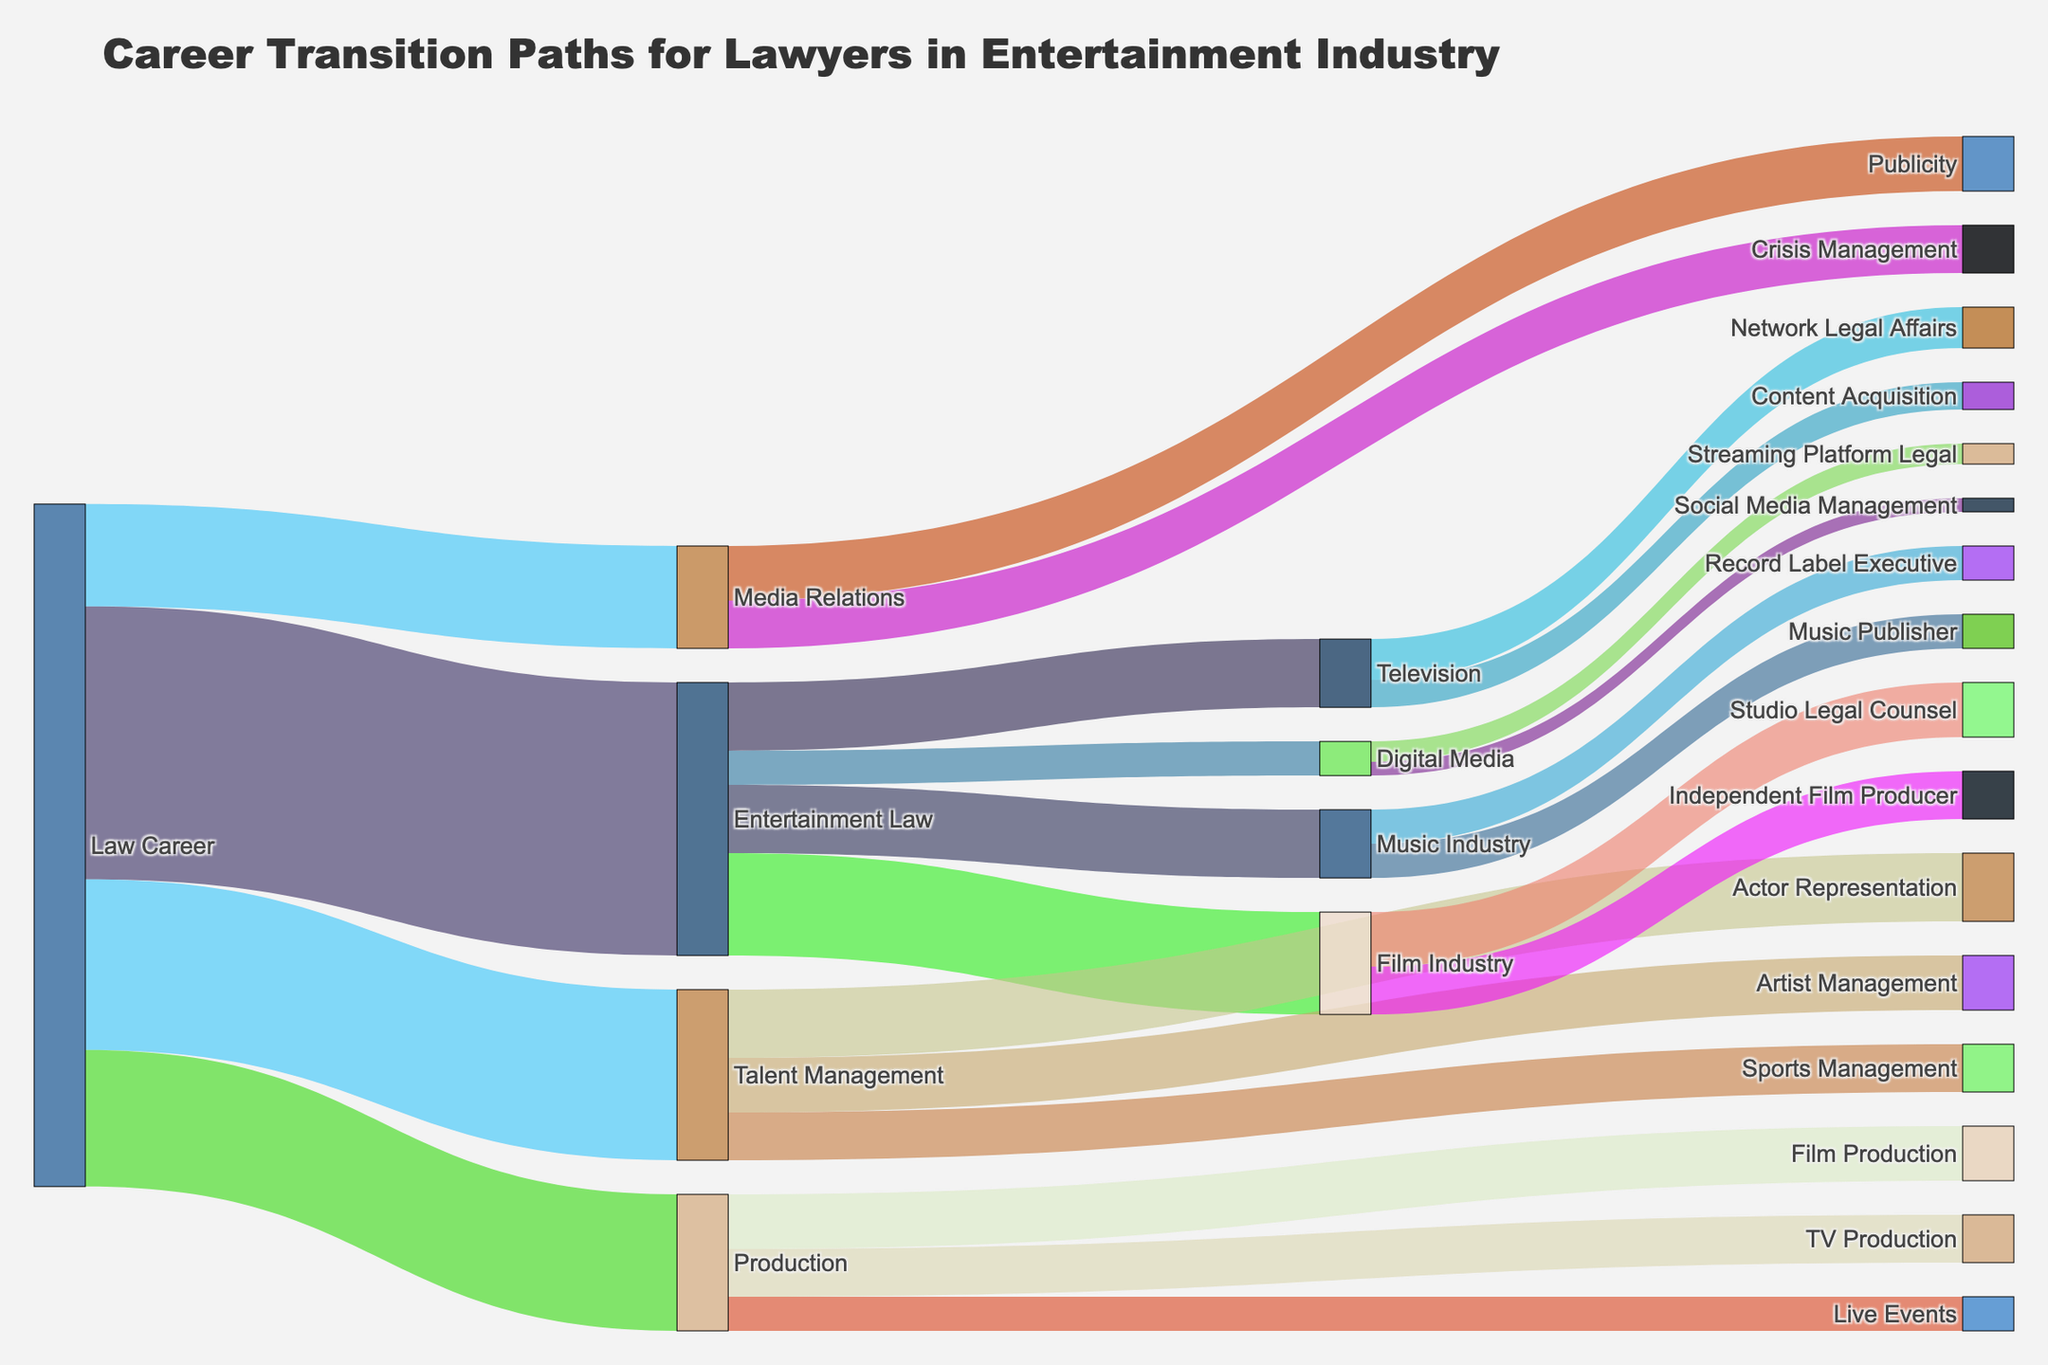How many different paths lead from a Law Career to roles in the Film Industry? There are two paths from a Law Career to roles in the Film Industry: (1) Law Career -> Entertainment Law -> Film Industry and (2) Law Career -> Production -> Film Production.
Answer: 2 Which transition has the highest value from a Law Career to a different role in the entertainment industry? The highest value transition from a Law Career to a different role is to Entertainment Law, with a value of 40.
Answer: Entertainment Law What is the total number of career transitions from Law Career to the Production sector, considering all sub-sectors of Production? The total number of transitions from Law Career to Production is the sum of the transitions to Film Production, TV Production, and Live Events. Adding the values: 8 + 7 + 5 = 20. This matches the value mentioned directly for Law Career -> Production.
Answer: 20 Which has a higher transition value: Talent Management to Actor Representation or Talent Management to Artist Management? Talent Management to Actor Representation has a value of 10, whereas Talent Management to Artist Management has a value of 8. Therefore, Talent Management to Actor Representation has a higher value.
Answer: Talent Management to Actor Representation How many total transitions go from Entertainment Law to specific industries like Film, Music, Television, and Digital Media? Sum the values of transitions from Entertainment Law to Film Industry, Music Industry, Television, and Digital Media, which are 15 + 10 + 10 + 5 = 40.
Answer: 40 How many more transitions are there from Media Relations to Publicity than from Media Relations to Crisis Management? Subtract the value from Media Relations to Crisis Management from that of Media Relations to Publicity: 8 - 7 = 1.
Answer: 1 Which sector has the fewest transitions involving a Law Career, considering initial transitions? The sector with the fewest transitions from a Law Career among the initial transitions is Media Relations, with a value of 15.
Answer: Media Relations 